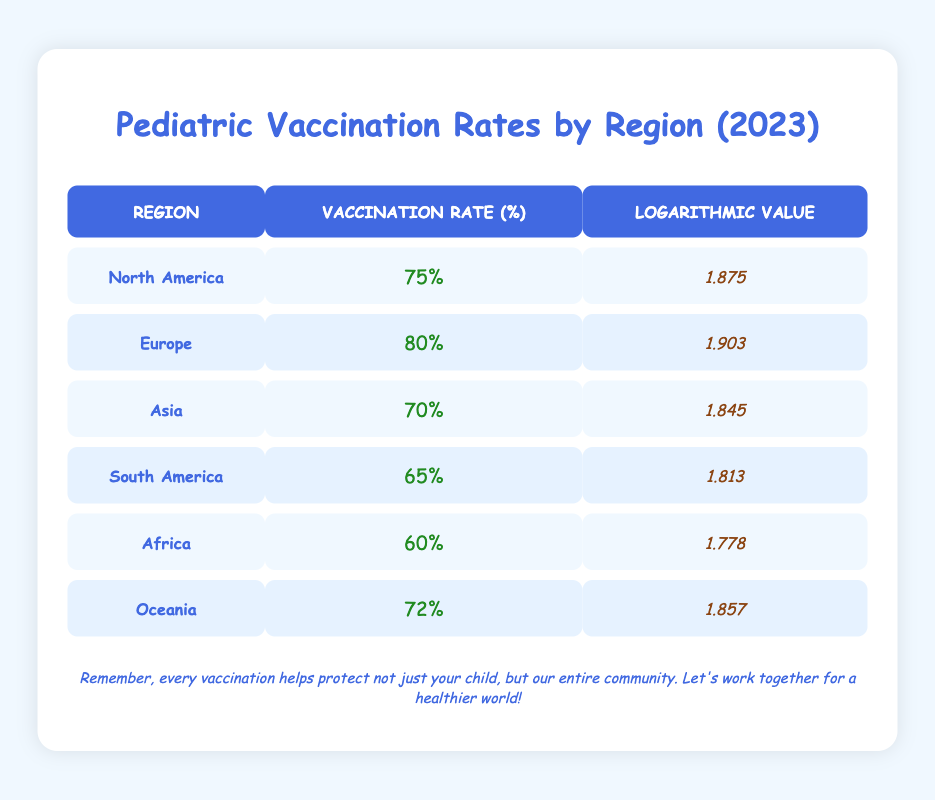What is the vaccination rate in Europe? From the table, Europe has a vaccination rate listed under the "Vaccination Rate (%)" column. The value is 80%.
Answer: 80% Which region has the lowest vaccination rate? By inspecting the "Vaccination Rate (%)" column, I can see that Africa has the lowest vaccination rate of 60%.
Answer: Africa What is the logarithmic value for South America? Looking at the "Logarithmic Value" column, South America has a logarithmic value of 1.813.
Answer: 1.813 What is the difference in vaccination rates between North America and Asia? The vaccination rate in North America is 75% and in Asia, it is 70%. The difference would be 75% - 70% = 5%.
Answer: 5% Is the vaccination rate in Oceania higher than in Africa? Oceania has a vaccination rate of 72%, while Africa has a rate of 60%. Since 72% is greater than 60%, the statement is true.
Answer: Yes What is the average vaccination rate of all regions listed? To find the average, add the vaccination rates: (75 + 80 + 70 + 65 + 60 + 72) = 422. There are 6 regions, so the average is 422 / 6 = 70.33%.
Answer: 70.33% Which region has a vaccination rate closest to the logarithmic value of 1.857? The logarithmic value of 1.857 corresponds to Oceania with a vaccination rate of 72%. Reviewing the table, this is the only match.
Answer: Oceania If we combined the vaccination rates of North America and South America, what would the total be? The rates are 75% for North America and 65% for South America. Adding these together gives 75% + 65% = 140%.
Answer: 140% How many regions have vaccination rates above 70%? The regions exceeding 70% are North America (75%), Europe (80%), and Oceania (72%). Counting them gives 3 regions.
Answer: 3 